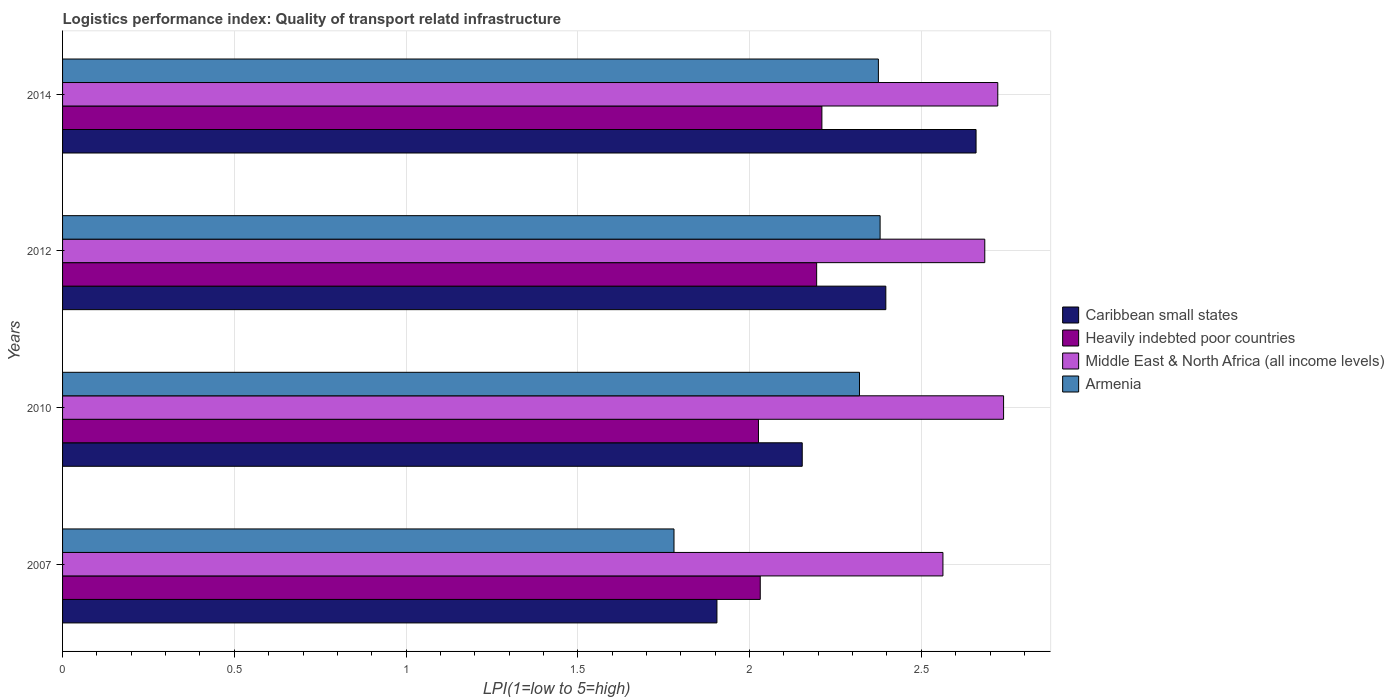Are the number of bars on each tick of the Y-axis equal?
Provide a succinct answer. Yes. How many bars are there on the 1st tick from the top?
Your answer should be compact. 4. What is the logistics performance index in Middle East & North Africa (all income levels) in 2010?
Your answer should be very brief. 2.74. Across all years, what is the maximum logistics performance index in Caribbean small states?
Keep it short and to the point. 2.66. Across all years, what is the minimum logistics performance index in Armenia?
Provide a succinct answer. 1.78. In which year was the logistics performance index in Armenia maximum?
Your answer should be very brief. 2012. In which year was the logistics performance index in Heavily indebted poor countries minimum?
Your answer should be compact. 2010. What is the total logistics performance index in Middle East & North Africa (all income levels) in the graph?
Your response must be concise. 10.71. What is the difference between the logistics performance index in Armenia in 2010 and that in 2014?
Ensure brevity in your answer.  -0.06. What is the difference between the logistics performance index in Middle East & North Africa (all income levels) in 2010 and the logistics performance index in Heavily indebted poor countries in 2014?
Keep it short and to the point. 0.53. What is the average logistics performance index in Middle East & North Africa (all income levels) per year?
Offer a very short reply. 2.68. In the year 2010, what is the difference between the logistics performance index in Caribbean small states and logistics performance index in Armenia?
Give a very brief answer. -0.17. What is the ratio of the logistics performance index in Heavily indebted poor countries in 2010 to that in 2014?
Ensure brevity in your answer.  0.92. Is the logistics performance index in Heavily indebted poor countries in 2007 less than that in 2012?
Make the answer very short. Yes. Is the difference between the logistics performance index in Caribbean small states in 2007 and 2014 greater than the difference between the logistics performance index in Armenia in 2007 and 2014?
Provide a succinct answer. No. What is the difference between the highest and the second highest logistics performance index in Middle East & North Africa (all income levels)?
Your answer should be compact. 0.02. What is the difference between the highest and the lowest logistics performance index in Caribbean small states?
Make the answer very short. 0.75. Is the sum of the logistics performance index in Caribbean small states in 2010 and 2012 greater than the maximum logistics performance index in Heavily indebted poor countries across all years?
Your answer should be very brief. Yes. What does the 1st bar from the top in 2007 represents?
Offer a terse response. Armenia. What does the 4th bar from the bottom in 2007 represents?
Your answer should be very brief. Armenia. Is it the case that in every year, the sum of the logistics performance index in Caribbean small states and logistics performance index in Armenia is greater than the logistics performance index in Heavily indebted poor countries?
Make the answer very short. Yes. How many bars are there?
Your answer should be compact. 16. Are all the bars in the graph horizontal?
Your answer should be compact. Yes. How many years are there in the graph?
Provide a short and direct response. 4. Does the graph contain any zero values?
Your response must be concise. No. Does the graph contain grids?
Give a very brief answer. Yes. What is the title of the graph?
Offer a very short reply. Logistics performance index: Quality of transport relatd infrastructure. Does "Guatemala" appear as one of the legend labels in the graph?
Your answer should be compact. No. What is the label or title of the X-axis?
Offer a terse response. LPI(1=low to 5=high). What is the label or title of the Y-axis?
Your response must be concise. Years. What is the LPI(1=low to 5=high) in Caribbean small states in 2007?
Provide a short and direct response. 1.91. What is the LPI(1=low to 5=high) of Heavily indebted poor countries in 2007?
Keep it short and to the point. 2.03. What is the LPI(1=low to 5=high) in Middle East & North Africa (all income levels) in 2007?
Your answer should be very brief. 2.56. What is the LPI(1=low to 5=high) of Armenia in 2007?
Ensure brevity in your answer.  1.78. What is the LPI(1=low to 5=high) in Caribbean small states in 2010?
Give a very brief answer. 2.15. What is the LPI(1=low to 5=high) of Heavily indebted poor countries in 2010?
Your answer should be very brief. 2.03. What is the LPI(1=low to 5=high) of Middle East & North Africa (all income levels) in 2010?
Your answer should be very brief. 2.74. What is the LPI(1=low to 5=high) in Armenia in 2010?
Ensure brevity in your answer.  2.32. What is the LPI(1=low to 5=high) of Caribbean small states in 2012?
Provide a succinct answer. 2.4. What is the LPI(1=low to 5=high) in Heavily indebted poor countries in 2012?
Keep it short and to the point. 2.2. What is the LPI(1=low to 5=high) of Middle East & North Africa (all income levels) in 2012?
Give a very brief answer. 2.68. What is the LPI(1=low to 5=high) of Armenia in 2012?
Provide a short and direct response. 2.38. What is the LPI(1=low to 5=high) in Caribbean small states in 2014?
Give a very brief answer. 2.66. What is the LPI(1=low to 5=high) of Heavily indebted poor countries in 2014?
Offer a very short reply. 2.21. What is the LPI(1=low to 5=high) of Middle East & North Africa (all income levels) in 2014?
Provide a short and direct response. 2.72. What is the LPI(1=low to 5=high) of Armenia in 2014?
Ensure brevity in your answer.  2.38. Across all years, what is the maximum LPI(1=low to 5=high) in Caribbean small states?
Make the answer very short. 2.66. Across all years, what is the maximum LPI(1=low to 5=high) in Heavily indebted poor countries?
Give a very brief answer. 2.21. Across all years, what is the maximum LPI(1=low to 5=high) of Middle East & North Africa (all income levels)?
Your answer should be compact. 2.74. Across all years, what is the maximum LPI(1=low to 5=high) in Armenia?
Offer a terse response. 2.38. Across all years, what is the minimum LPI(1=low to 5=high) in Caribbean small states?
Offer a very short reply. 1.91. Across all years, what is the minimum LPI(1=low to 5=high) of Heavily indebted poor countries?
Offer a very short reply. 2.03. Across all years, what is the minimum LPI(1=low to 5=high) of Middle East & North Africa (all income levels)?
Make the answer very short. 2.56. Across all years, what is the minimum LPI(1=low to 5=high) in Armenia?
Make the answer very short. 1.78. What is the total LPI(1=low to 5=high) of Caribbean small states in the graph?
Provide a short and direct response. 9.11. What is the total LPI(1=low to 5=high) of Heavily indebted poor countries in the graph?
Give a very brief answer. 8.46. What is the total LPI(1=low to 5=high) of Middle East & North Africa (all income levels) in the graph?
Provide a short and direct response. 10.71. What is the total LPI(1=low to 5=high) of Armenia in the graph?
Your answer should be very brief. 8.86. What is the difference between the LPI(1=low to 5=high) in Caribbean small states in 2007 and that in 2010?
Offer a terse response. -0.25. What is the difference between the LPI(1=low to 5=high) of Heavily indebted poor countries in 2007 and that in 2010?
Make the answer very short. 0.01. What is the difference between the LPI(1=low to 5=high) in Middle East & North Africa (all income levels) in 2007 and that in 2010?
Offer a very short reply. -0.18. What is the difference between the LPI(1=low to 5=high) in Armenia in 2007 and that in 2010?
Offer a very short reply. -0.54. What is the difference between the LPI(1=low to 5=high) of Caribbean small states in 2007 and that in 2012?
Ensure brevity in your answer.  -0.49. What is the difference between the LPI(1=low to 5=high) of Heavily indebted poor countries in 2007 and that in 2012?
Make the answer very short. -0.16. What is the difference between the LPI(1=low to 5=high) in Middle East & North Africa (all income levels) in 2007 and that in 2012?
Offer a terse response. -0.12. What is the difference between the LPI(1=low to 5=high) in Caribbean small states in 2007 and that in 2014?
Offer a terse response. -0.75. What is the difference between the LPI(1=low to 5=high) in Heavily indebted poor countries in 2007 and that in 2014?
Your answer should be very brief. -0.18. What is the difference between the LPI(1=low to 5=high) of Middle East & North Africa (all income levels) in 2007 and that in 2014?
Give a very brief answer. -0.16. What is the difference between the LPI(1=low to 5=high) of Armenia in 2007 and that in 2014?
Make the answer very short. -0.59. What is the difference between the LPI(1=low to 5=high) of Caribbean small states in 2010 and that in 2012?
Provide a short and direct response. -0.24. What is the difference between the LPI(1=low to 5=high) in Heavily indebted poor countries in 2010 and that in 2012?
Ensure brevity in your answer.  -0.17. What is the difference between the LPI(1=low to 5=high) in Middle East & North Africa (all income levels) in 2010 and that in 2012?
Provide a short and direct response. 0.05. What is the difference between the LPI(1=low to 5=high) in Armenia in 2010 and that in 2012?
Offer a terse response. -0.06. What is the difference between the LPI(1=low to 5=high) of Caribbean small states in 2010 and that in 2014?
Offer a terse response. -0.51. What is the difference between the LPI(1=low to 5=high) in Heavily indebted poor countries in 2010 and that in 2014?
Offer a terse response. -0.18. What is the difference between the LPI(1=low to 5=high) in Middle East & North Africa (all income levels) in 2010 and that in 2014?
Make the answer very short. 0.02. What is the difference between the LPI(1=low to 5=high) of Armenia in 2010 and that in 2014?
Keep it short and to the point. -0.06. What is the difference between the LPI(1=low to 5=high) in Caribbean small states in 2012 and that in 2014?
Offer a terse response. -0.26. What is the difference between the LPI(1=low to 5=high) in Heavily indebted poor countries in 2012 and that in 2014?
Your answer should be very brief. -0.02. What is the difference between the LPI(1=low to 5=high) in Middle East & North Africa (all income levels) in 2012 and that in 2014?
Offer a very short reply. -0.04. What is the difference between the LPI(1=low to 5=high) in Armenia in 2012 and that in 2014?
Your answer should be compact. 0.01. What is the difference between the LPI(1=low to 5=high) in Caribbean small states in 2007 and the LPI(1=low to 5=high) in Heavily indebted poor countries in 2010?
Provide a succinct answer. -0.12. What is the difference between the LPI(1=low to 5=high) in Caribbean small states in 2007 and the LPI(1=low to 5=high) in Middle East & North Africa (all income levels) in 2010?
Keep it short and to the point. -0.83. What is the difference between the LPI(1=low to 5=high) of Caribbean small states in 2007 and the LPI(1=low to 5=high) of Armenia in 2010?
Keep it short and to the point. -0.41. What is the difference between the LPI(1=low to 5=high) of Heavily indebted poor countries in 2007 and the LPI(1=low to 5=high) of Middle East & North Africa (all income levels) in 2010?
Ensure brevity in your answer.  -0.71. What is the difference between the LPI(1=low to 5=high) of Heavily indebted poor countries in 2007 and the LPI(1=low to 5=high) of Armenia in 2010?
Provide a short and direct response. -0.29. What is the difference between the LPI(1=low to 5=high) in Middle East & North Africa (all income levels) in 2007 and the LPI(1=low to 5=high) in Armenia in 2010?
Keep it short and to the point. 0.24. What is the difference between the LPI(1=low to 5=high) in Caribbean small states in 2007 and the LPI(1=low to 5=high) in Heavily indebted poor countries in 2012?
Provide a short and direct response. -0.29. What is the difference between the LPI(1=low to 5=high) of Caribbean small states in 2007 and the LPI(1=low to 5=high) of Middle East & North Africa (all income levels) in 2012?
Give a very brief answer. -0.78. What is the difference between the LPI(1=low to 5=high) in Caribbean small states in 2007 and the LPI(1=low to 5=high) in Armenia in 2012?
Give a very brief answer. -0.47. What is the difference between the LPI(1=low to 5=high) in Heavily indebted poor countries in 2007 and the LPI(1=low to 5=high) in Middle East & North Africa (all income levels) in 2012?
Make the answer very short. -0.65. What is the difference between the LPI(1=low to 5=high) in Heavily indebted poor countries in 2007 and the LPI(1=low to 5=high) in Armenia in 2012?
Provide a succinct answer. -0.35. What is the difference between the LPI(1=low to 5=high) in Middle East & North Africa (all income levels) in 2007 and the LPI(1=low to 5=high) in Armenia in 2012?
Your response must be concise. 0.18. What is the difference between the LPI(1=low to 5=high) of Caribbean small states in 2007 and the LPI(1=low to 5=high) of Heavily indebted poor countries in 2014?
Ensure brevity in your answer.  -0.31. What is the difference between the LPI(1=low to 5=high) in Caribbean small states in 2007 and the LPI(1=low to 5=high) in Middle East & North Africa (all income levels) in 2014?
Your response must be concise. -0.82. What is the difference between the LPI(1=low to 5=high) in Caribbean small states in 2007 and the LPI(1=low to 5=high) in Armenia in 2014?
Offer a very short reply. -0.47. What is the difference between the LPI(1=low to 5=high) of Heavily indebted poor countries in 2007 and the LPI(1=low to 5=high) of Middle East & North Africa (all income levels) in 2014?
Offer a terse response. -0.69. What is the difference between the LPI(1=low to 5=high) in Heavily indebted poor countries in 2007 and the LPI(1=low to 5=high) in Armenia in 2014?
Offer a very short reply. -0.34. What is the difference between the LPI(1=low to 5=high) of Middle East & North Africa (all income levels) in 2007 and the LPI(1=low to 5=high) of Armenia in 2014?
Give a very brief answer. 0.19. What is the difference between the LPI(1=low to 5=high) of Caribbean small states in 2010 and the LPI(1=low to 5=high) of Heavily indebted poor countries in 2012?
Your answer should be very brief. -0.04. What is the difference between the LPI(1=low to 5=high) of Caribbean small states in 2010 and the LPI(1=low to 5=high) of Middle East & North Africa (all income levels) in 2012?
Make the answer very short. -0.53. What is the difference between the LPI(1=low to 5=high) in Caribbean small states in 2010 and the LPI(1=low to 5=high) in Armenia in 2012?
Provide a short and direct response. -0.23. What is the difference between the LPI(1=low to 5=high) of Heavily indebted poor countries in 2010 and the LPI(1=low to 5=high) of Middle East & North Africa (all income levels) in 2012?
Ensure brevity in your answer.  -0.66. What is the difference between the LPI(1=low to 5=high) of Heavily indebted poor countries in 2010 and the LPI(1=low to 5=high) of Armenia in 2012?
Offer a very short reply. -0.35. What is the difference between the LPI(1=low to 5=high) in Middle East & North Africa (all income levels) in 2010 and the LPI(1=low to 5=high) in Armenia in 2012?
Your response must be concise. 0.36. What is the difference between the LPI(1=low to 5=high) in Caribbean small states in 2010 and the LPI(1=low to 5=high) in Heavily indebted poor countries in 2014?
Give a very brief answer. -0.06. What is the difference between the LPI(1=low to 5=high) in Caribbean small states in 2010 and the LPI(1=low to 5=high) in Middle East & North Africa (all income levels) in 2014?
Provide a succinct answer. -0.57. What is the difference between the LPI(1=low to 5=high) in Caribbean small states in 2010 and the LPI(1=low to 5=high) in Armenia in 2014?
Keep it short and to the point. -0.22. What is the difference between the LPI(1=low to 5=high) of Heavily indebted poor countries in 2010 and the LPI(1=low to 5=high) of Middle East & North Africa (all income levels) in 2014?
Offer a very short reply. -0.7. What is the difference between the LPI(1=low to 5=high) in Heavily indebted poor countries in 2010 and the LPI(1=low to 5=high) in Armenia in 2014?
Your answer should be compact. -0.35. What is the difference between the LPI(1=low to 5=high) in Middle East & North Africa (all income levels) in 2010 and the LPI(1=low to 5=high) in Armenia in 2014?
Your answer should be compact. 0.36. What is the difference between the LPI(1=low to 5=high) in Caribbean small states in 2012 and the LPI(1=low to 5=high) in Heavily indebted poor countries in 2014?
Offer a very short reply. 0.19. What is the difference between the LPI(1=low to 5=high) of Caribbean small states in 2012 and the LPI(1=low to 5=high) of Middle East & North Africa (all income levels) in 2014?
Your response must be concise. -0.33. What is the difference between the LPI(1=low to 5=high) of Caribbean small states in 2012 and the LPI(1=low to 5=high) of Armenia in 2014?
Provide a succinct answer. 0.02. What is the difference between the LPI(1=low to 5=high) in Heavily indebted poor countries in 2012 and the LPI(1=low to 5=high) in Middle East & North Africa (all income levels) in 2014?
Make the answer very short. -0.53. What is the difference between the LPI(1=low to 5=high) in Heavily indebted poor countries in 2012 and the LPI(1=low to 5=high) in Armenia in 2014?
Offer a terse response. -0.18. What is the difference between the LPI(1=low to 5=high) of Middle East & North Africa (all income levels) in 2012 and the LPI(1=low to 5=high) of Armenia in 2014?
Ensure brevity in your answer.  0.31. What is the average LPI(1=low to 5=high) of Caribbean small states per year?
Your answer should be compact. 2.28. What is the average LPI(1=low to 5=high) of Heavily indebted poor countries per year?
Provide a short and direct response. 2.12. What is the average LPI(1=low to 5=high) of Middle East & North Africa (all income levels) per year?
Ensure brevity in your answer.  2.68. What is the average LPI(1=low to 5=high) of Armenia per year?
Give a very brief answer. 2.21. In the year 2007, what is the difference between the LPI(1=low to 5=high) of Caribbean small states and LPI(1=low to 5=high) of Heavily indebted poor countries?
Offer a very short reply. -0.13. In the year 2007, what is the difference between the LPI(1=low to 5=high) in Caribbean small states and LPI(1=low to 5=high) in Middle East & North Africa (all income levels)?
Your answer should be very brief. -0.66. In the year 2007, what is the difference between the LPI(1=low to 5=high) of Heavily indebted poor countries and LPI(1=low to 5=high) of Middle East & North Africa (all income levels)?
Give a very brief answer. -0.53. In the year 2007, what is the difference between the LPI(1=low to 5=high) in Heavily indebted poor countries and LPI(1=low to 5=high) in Armenia?
Your answer should be compact. 0.25. In the year 2007, what is the difference between the LPI(1=low to 5=high) of Middle East & North Africa (all income levels) and LPI(1=low to 5=high) of Armenia?
Give a very brief answer. 0.78. In the year 2010, what is the difference between the LPI(1=low to 5=high) of Caribbean small states and LPI(1=low to 5=high) of Heavily indebted poor countries?
Make the answer very short. 0.13. In the year 2010, what is the difference between the LPI(1=low to 5=high) of Caribbean small states and LPI(1=low to 5=high) of Middle East & North Africa (all income levels)?
Your answer should be very brief. -0.59. In the year 2010, what is the difference between the LPI(1=low to 5=high) in Caribbean small states and LPI(1=low to 5=high) in Armenia?
Keep it short and to the point. -0.17. In the year 2010, what is the difference between the LPI(1=low to 5=high) in Heavily indebted poor countries and LPI(1=low to 5=high) in Middle East & North Africa (all income levels)?
Provide a short and direct response. -0.71. In the year 2010, what is the difference between the LPI(1=low to 5=high) in Heavily indebted poor countries and LPI(1=low to 5=high) in Armenia?
Your answer should be very brief. -0.29. In the year 2010, what is the difference between the LPI(1=low to 5=high) in Middle East & North Africa (all income levels) and LPI(1=low to 5=high) in Armenia?
Offer a very short reply. 0.42. In the year 2012, what is the difference between the LPI(1=low to 5=high) of Caribbean small states and LPI(1=low to 5=high) of Heavily indebted poor countries?
Your response must be concise. 0.2. In the year 2012, what is the difference between the LPI(1=low to 5=high) in Caribbean small states and LPI(1=low to 5=high) in Middle East & North Africa (all income levels)?
Give a very brief answer. -0.29. In the year 2012, what is the difference between the LPI(1=low to 5=high) of Caribbean small states and LPI(1=low to 5=high) of Armenia?
Make the answer very short. 0.02. In the year 2012, what is the difference between the LPI(1=low to 5=high) in Heavily indebted poor countries and LPI(1=low to 5=high) in Middle East & North Africa (all income levels)?
Provide a short and direct response. -0.49. In the year 2012, what is the difference between the LPI(1=low to 5=high) of Heavily indebted poor countries and LPI(1=low to 5=high) of Armenia?
Offer a terse response. -0.18. In the year 2012, what is the difference between the LPI(1=low to 5=high) of Middle East & North Africa (all income levels) and LPI(1=low to 5=high) of Armenia?
Offer a terse response. 0.3. In the year 2014, what is the difference between the LPI(1=low to 5=high) of Caribbean small states and LPI(1=low to 5=high) of Heavily indebted poor countries?
Ensure brevity in your answer.  0.45. In the year 2014, what is the difference between the LPI(1=low to 5=high) of Caribbean small states and LPI(1=low to 5=high) of Middle East & North Africa (all income levels)?
Offer a very short reply. -0.06. In the year 2014, what is the difference between the LPI(1=low to 5=high) in Caribbean small states and LPI(1=low to 5=high) in Armenia?
Give a very brief answer. 0.28. In the year 2014, what is the difference between the LPI(1=low to 5=high) in Heavily indebted poor countries and LPI(1=low to 5=high) in Middle East & North Africa (all income levels)?
Offer a terse response. -0.51. In the year 2014, what is the difference between the LPI(1=low to 5=high) of Heavily indebted poor countries and LPI(1=low to 5=high) of Armenia?
Keep it short and to the point. -0.16. In the year 2014, what is the difference between the LPI(1=low to 5=high) in Middle East & North Africa (all income levels) and LPI(1=low to 5=high) in Armenia?
Your answer should be very brief. 0.35. What is the ratio of the LPI(1=low to 5=high) in Caribbean small states in 2007 to that in 2010?
Offer a terse response. 0.88. What is the ratio of the LPI(1=low to 5=high) of Middle East & North Africa (all income levels) in 2007 to that in 2010?
Your answer should be very brief. 0.94. What is the ratio of the LPI(1=low to 5=high) of Armenia in 2007 to that in 2010?
Provide a succinct answer. 0.77. What is the ratio of the LPI(1=low to 5=high) of Caribbean small states in 2007 to that in 2012?
Make the answer very short. 0.79. What is the ratio of the LPI(1=low to 5=high) in Heavily indebted poor countries in 2007 to that in 2012?
Your answer should be compact. 0.93. What is the ratio of the LPI(1=low to 5=high) of Middle East & North Africa (all income levels) in 2007 to that in 2012?
Provide a short and direct response. 0.95. What is the ratio of the LPI(1=low to 5=high) of Armenia in 2007 to that in 2012?
Offer a terse response. 0.75. What is the ratio of the LPI(1=low to 5=high) of Caribbean small states in 2007 to that in 2014?
Make the answer very short. 0.72. What is the ratio of the LPI(1=low to 5=high) in Heavily indebted poor countries in 2007 to that in 2014?
Make the answer very short. 0.92. What is the ratio of the LPI(1=low to 5=high) in Middle East & North Africa (all income levels) in 2007 to that in 2014?
Make the answer very short. 0.94. What is the ratio of the LPI(1=low to 5=high) of Armenia in 2007 to that in 2014?
Your answer should be very brief. 0.75. What is the ratio of the LPI(1=low to 5=high) of Caribbean small states in 2010 to that in 2012?
Your answer should be compact. 0.9. What is the ratio of the LPI(1=low to 5=high) in Heavily indebted poor countries in 2010 to that in 2012?
Provide a short and direct response. 0.92. What is the ratio of the LPI(1=low to 5=high) of Middle East & North Africa (all income levels) in 2010 to that in 2012?
Provide a succinct answer. 1.02. What is the ratio of the LPI(1=low to 5=high) of Armenia in 2010 to that in 2012?
Your answer should be compact. 0.97. What is the ratio of the LPI(1=low to 5=high) of Caribbean small states in 2010 to that in 2014?
Keep it short and to the point. 0.81. What is the ratio of the LPI(1=low to 5=high) in Heavily indebted poor countries in 2010 to that in 2014?
Keep it short and to the point. 0.92. What is the ratio of the LPI(1=low to 5=high) in Armenia in 2010 to that in 2014?
Offer a very short reply. 0.98. What is the ratio of the LPI(1=low to 5=high) in Caribbean small states in 2012 to that in 2014?
Provide a succinct answer. 0.9. What is the ratio of the LPI(1=low to 5=high) in Heavily indebted poor countries in 2012 to that in 2014?
Make the answer very short. 0.99. What is the ratio of the LPI(1=low to 5=high) in Middle East & North Africa (all income levels) in 2012 to that in 2014?
Give a very brief answer. 0.99. What is the difference between the highest and the second highest LPI(1=low to 5=high) in Caribbean small states?
Your response must be concise. 0.26. What is the difference between the highest and the second highest LPI(1=low to 5=high) in Heavily indebted poor countries?
Your response must be concise. 0.02. What is the difference between the highest and the second highest LPI(1=low to 5=high) of Middle East & North Africa (all income levels)?
Your response must be concise. 0.02. What is the difference between the highest and the second highest LPI(1=low to 5=high) in Armenia?
Give a very brief answer. 0.01. What is the difference between the highest and the lowest LPI(1=low to 5=high) of Caribbean small states?
Make the answer very short. 0.75. What is the difference between the highest and the lowest LPI(1=low to 5=high) of Heavily indebted poor countries?
Give a very brief answer. 0.18. What is the difference between the highest and the lowest LPI(1=low to 5=high) of Middle East & North Africa (all income levels)?
Give a very brief answer. 0.18. What is the difference between the highest and the lowest LPI(1=low to 5=high) in Armenia?
Make the answer very short. 0.6. 